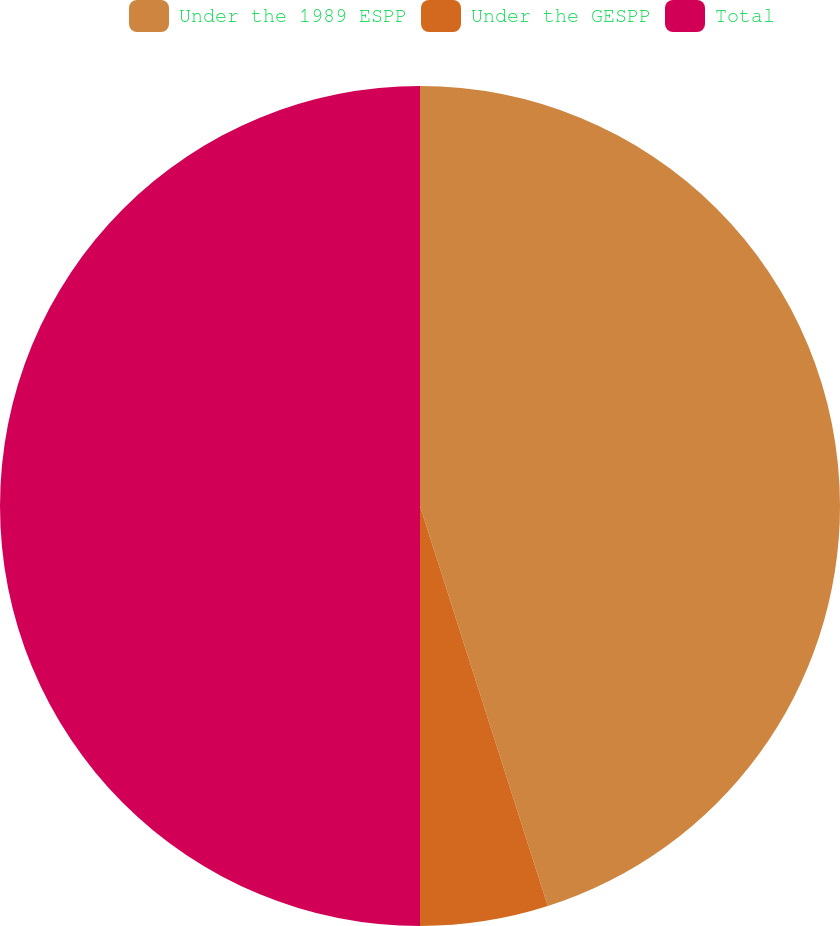Convert chart. <chart><loc_0><loc_0><loc_500><loc_500><pie_chart><fcel>Under the 1989 ESPP<fcel>Under the GESPP<fcel>Total<nl><fcel>45.08%<fcel>4.92%<fcel>50.0%<nl></chart> 